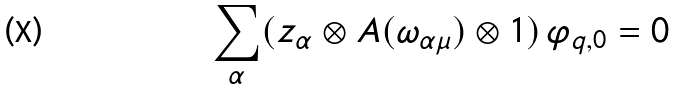Convert formula to latex. <formula><loc_0><loc_0><loc_500><loc_500>\sum _ { \alpha } ( z _ { \alpha } \otimes A ( \omega _ { \alpha \mu } ) \otimes 1 ) \, \varphi _ { q , 0 } = 0</formula> 